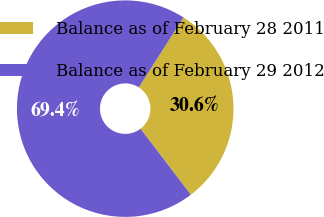<chart> <loc_0><loc_0><loc_500><loc_500><pie_chart><fcel>Balance as of February 28 2011<fcel>Balance as of February 29 2012<nl><fcel>30.59%<fcel>69.41%<nl></chart> 